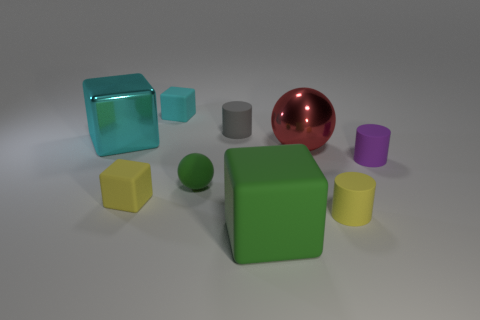Subtract all tiny cyan cubes. How many cubes are left? 3 Subtract all red balls. How many balls are left? 1 Subtract all red balls. How many cyan blocks are left? 2 Subtract 2 blocks. How many blocks are left? 2 Add 7 large red shiny balls. How many large red shiny balls exist? 8 Subtract 1 yellow cylinders. How many objects are left? 8 Subtract all cylinders. How many objects are left? 6 Subtract all yellow blocks. Subtract all brown cylinders. How many blocks are left? 3 Subtract all large green objects. Subtract all large cyan metal cubes. How many objects are left? 7 Add 4 large cyan metallic things. How many large cyan metallic things are left? 5 